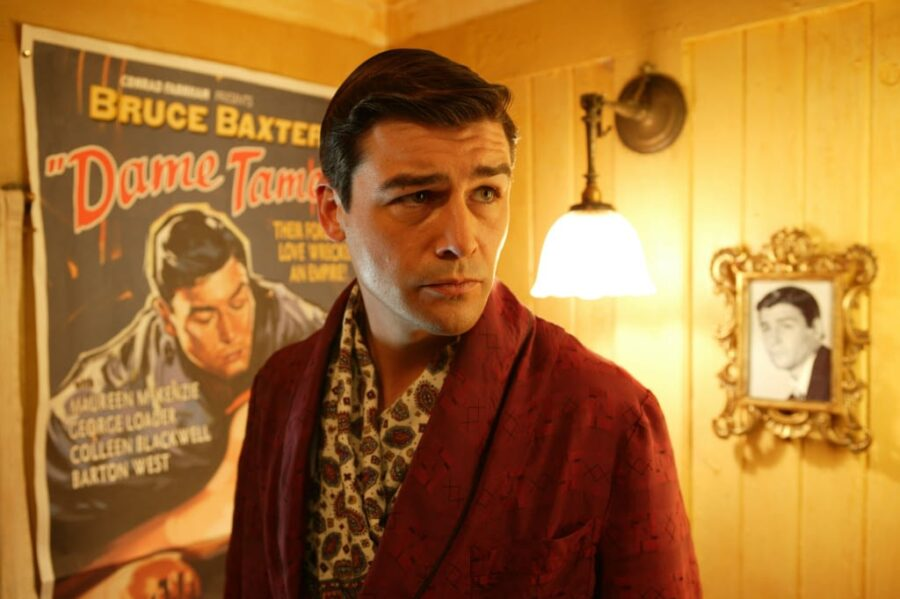Can you describe the mood conveyed by the actor's expression and setting? The actor's serious expression, combined with the warm, golden lighting of the room, portrays a mood of intensity yet elegance. This mood is further underscored by the plush, vintage decor and the soft glow from the lamp, creating a thoughtful and somewhat introspective atmosphere. 